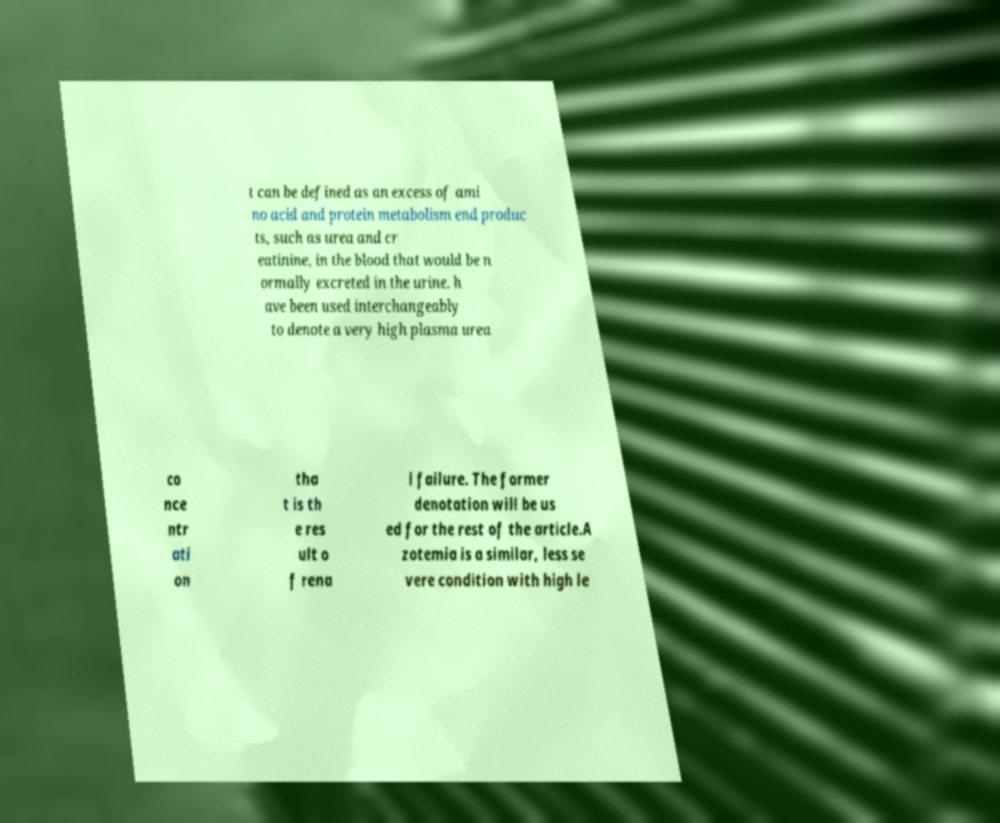Please identify and transcribe the text found in this image. t can be defined as an excess of ami no acid and protein metabolism end produc ts, such as urea and cr eatinine, in the blood that would be n ormally excreted in the urine. h ave been used interchangeably to denote a very high plasma urea co nce ntr ati on tha t is th e res ult o f rena l failure. The former denotation will be us ed for the rest of the article.A zotemia is a similar, less se vere condition with high le 